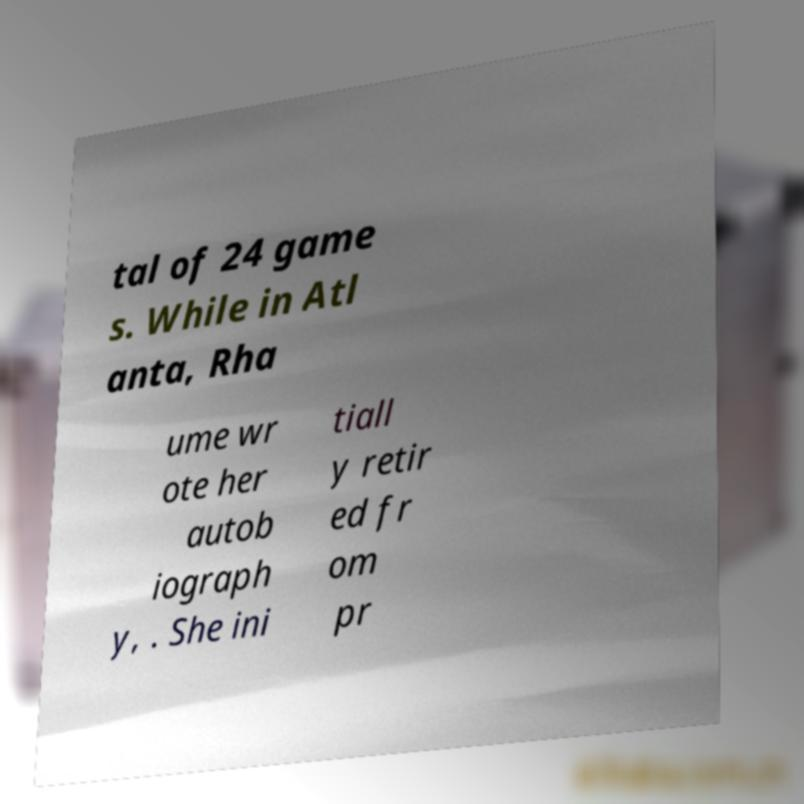I need the written content from this picture converted into text. Can you do that? tal of 24 game s. While in Atl anta, Rha ume wr ote her autob iograph y, . She ini tiall y retir ed fr om pr 